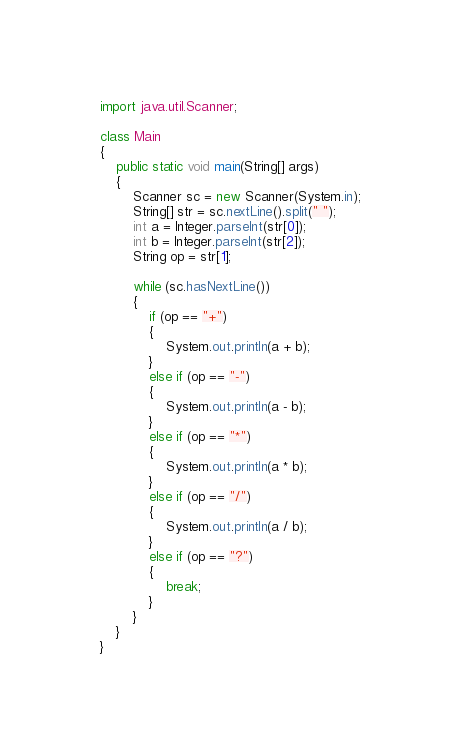Convert code to text. <code><loc_0><loc_0><loc_500><loc_500><_Java_>import java.util.Scanner;

class Main
{
	public static void main(String[] args)
	{
		Scanner sc = new Scanner(System.in);
		String[] str = sc.nextLine().split(" ");
		int a = Integer.parseInt(str[0]);
		int b = Integer.parseInt(str[2]);
		String op = str[1];
		
		while (sc.hasNextLine())
		{
			if (op == "+")
			{
				System.out.println(a + b);
			}
			else if (op == "-")
			{
				System.out.println(a - b);
			}
			else if (op == "*")
			{
				System.out.println(a * b);
			}
			else if (op == "/")
			{
				System.out.println(a / b);
			}
			else if (op == "?")
			{
				break;
			}
		}
	}
}</code> 